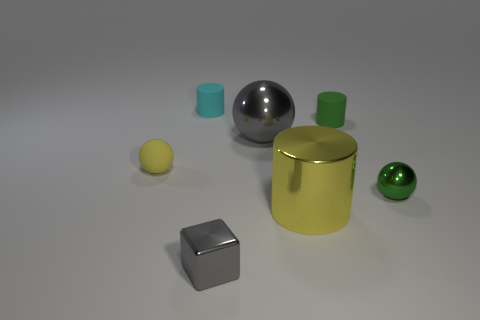There is a large metal cylinder; is its color the same as the tiny ball left of the block?
Ensure brevity in your answer.  Yes. Are there any other things that have the same shape as the yellow rubber object?
Your answer should be compact. Yes. What is the color of the thing that is behind the small cylinder that is to the right of the gray block?
Your answer should be compact. Cyan. What number of matte spheres are there?
Ensure brevity in your answer.  1. What number of matte things are red cylinders or big yellow cylinders?
Your response must be concise. 0. How many other metal cylinders are the same color as the large metal cylinder?
Make the answer very short. 0. What is the small sphere that is right of the gray thing left of the big sphere made of?
Your answer should be compact. Metal. What is the size of the cube?
Make the answer very short. Small. What number of cyan shiny balls have the same size as the shiny block?
Ensure brevity in your answer.  0. What number of tiny yellow things have the same shape as the small gray object?
Provide a short and direct response. 0. 